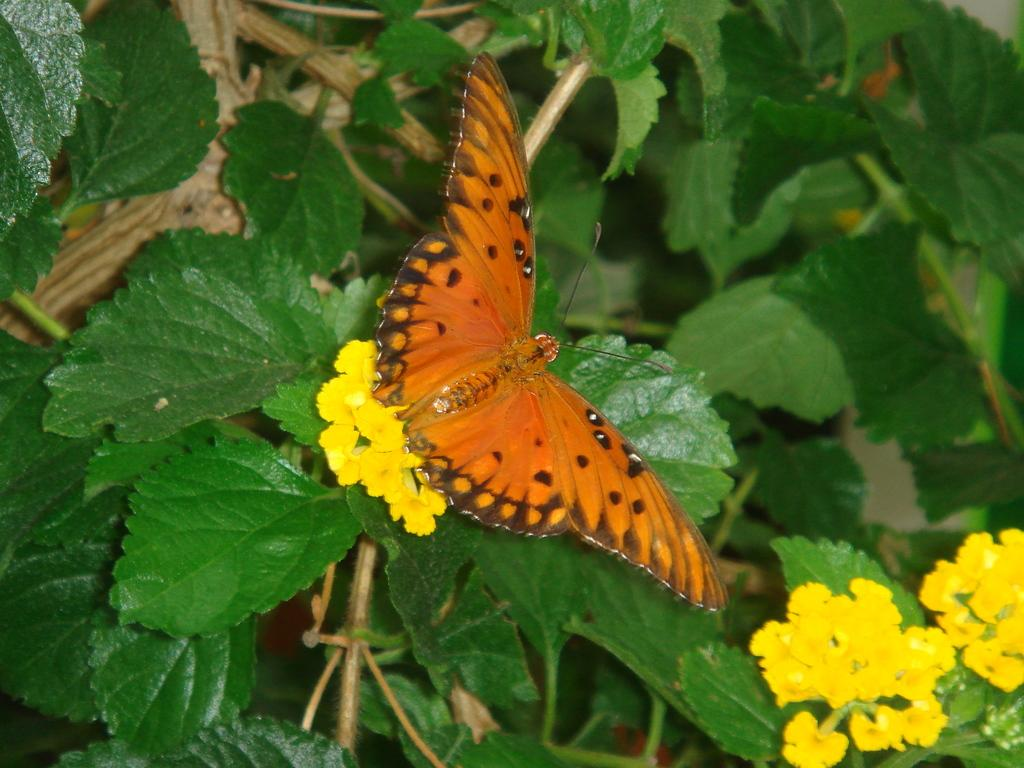What type of plant life is present in the image? There are stems with leaves in the image. Are there any flowers on the stems? Yes, there are flowers on the stems. What can be seen on the flowers in the image? There is a butterfly on the flowers. How many people are participating in the operation shown in the image? There is no operation present in the image; it features stems with leaves, flowers, and a butterfly. How many bikes are visible in the image? There are no bikes present in the image. 